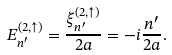Convert formula to latex. <formula><loc_0><loc_0><loc_500><loc_500>E _ { n ^ { \prime } } ^ { ( 2 , \uparrow ) } = \frac { \xi _ { n ^ { \prime } } ^ { ( 2 , \uparrow ) } } { 2 a } = - i \frac { n ^ { \prime } } { 2 a } .</formula> 